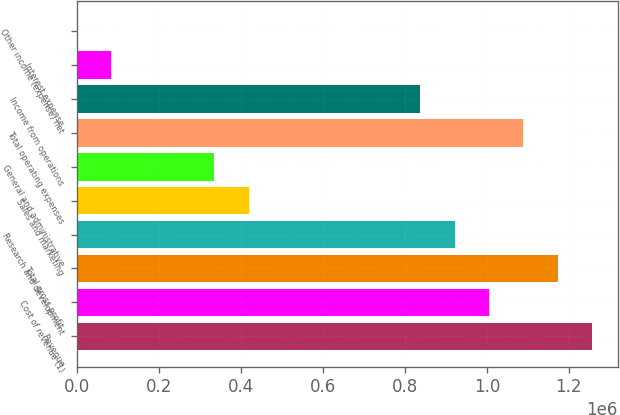Convert chart. <chart><loc_0><loc_0><loc_500><loc_500><bar_chart><fcel>Revenue<fcel>Cost of revenue (1)<fcel>Total gross profit<fcel>Research and development<fcel>Sales and marketing<fcel>General and administrative<fcel>Total operating expenses<fcel>Income from operations<fcel>Interest expense<fcel>Other income (expense) net<nl><fcel>1.25631e+06<fcel>1.00508e+06<fcel>1.17257e+06<fcel>921335<fcel>418869<fcel>335125<fcel>1.08882e+06<fcel>837591<fcel>83891.4<fcel>147<nl></chart> 